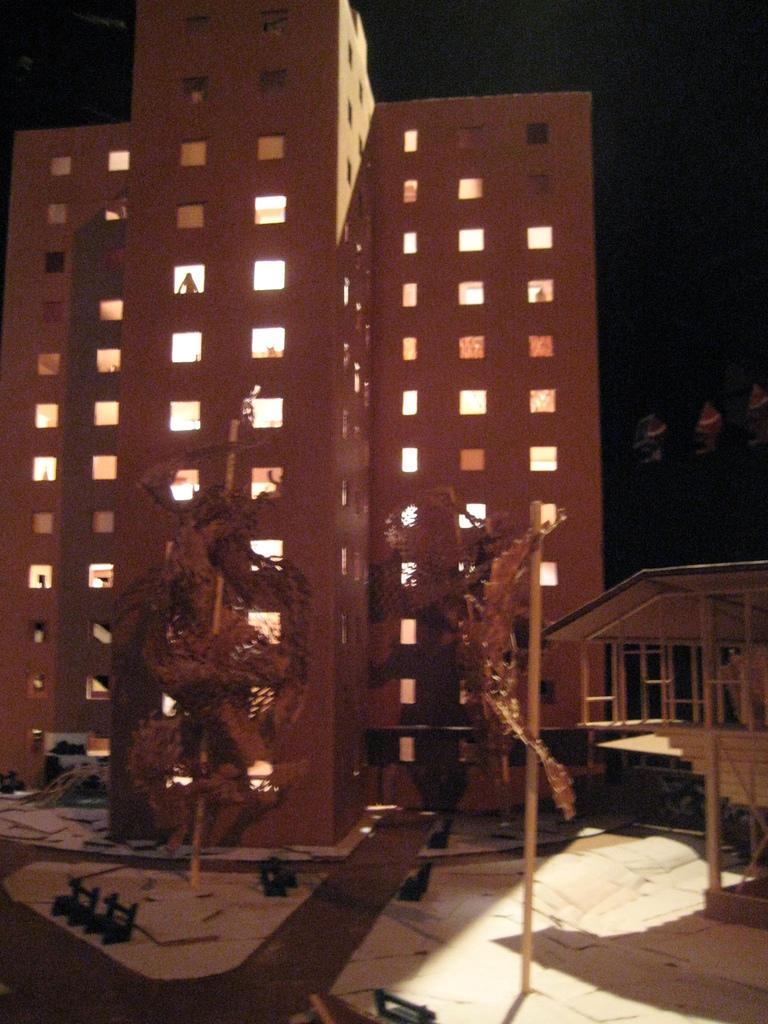What is the main structure in the center of the image? There is a building and a shed in the center of the image. What else can be seen in the center of the image besides the building and shed? Poles are present in the center of the image. What is located at the bottom of the image? Benches are visible at the bottom of the image, and the ground is also present. What is visible at the top of the image? The sky is visible at the top of the image. How many sticks are being used by the porter in the image? There is no porter or sticks present in the image. What type of quilt is draped over the building in the image? There is no quilt present in the image; it features a building, a shed, poles, benches, the ground, and the sky. 